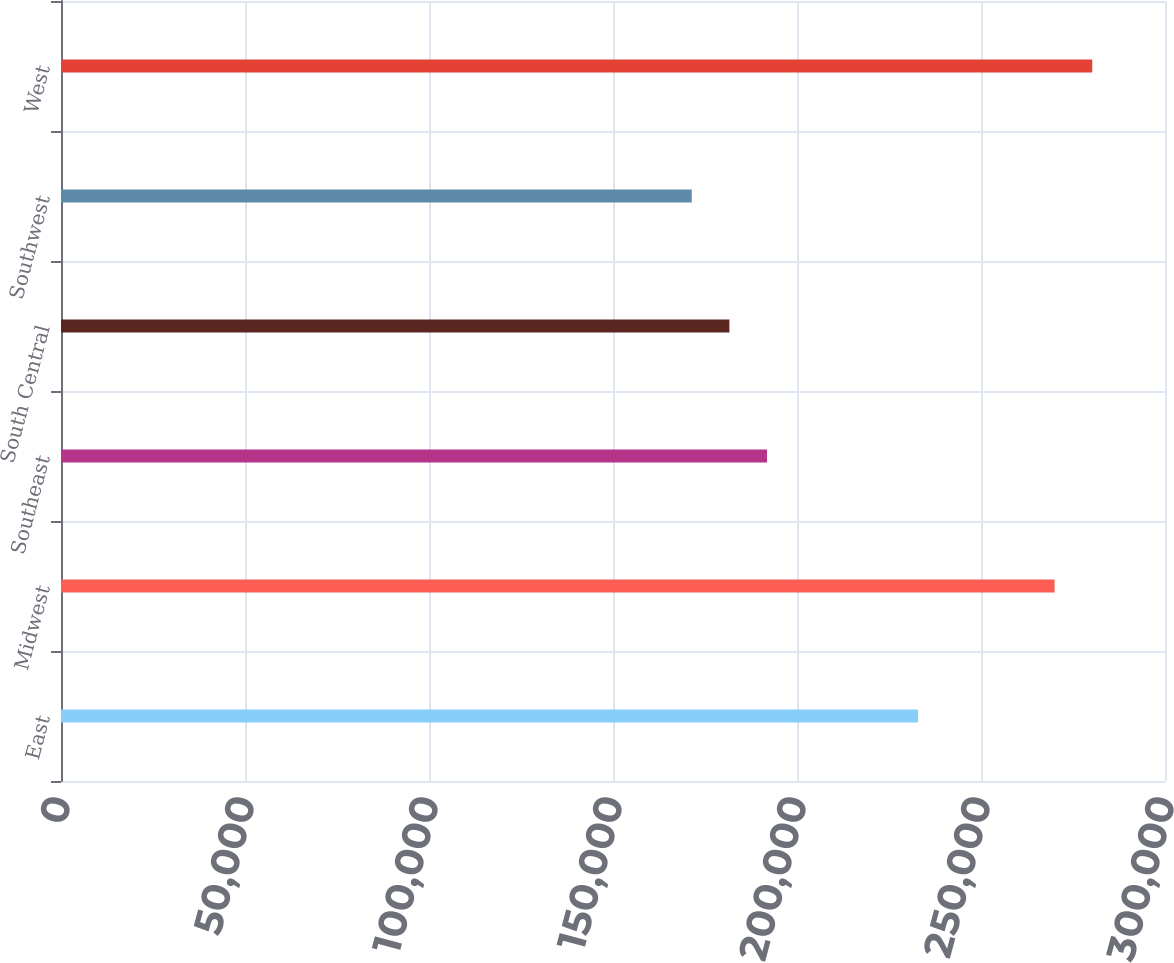Convert chart. <chart><loc_0><loc_0><loc_500><loc_500><bar_chart><fcel>East<fcel>Midwest<fcel>Southeast<fcel>South Central<fcel>Southwest<fcel>West<nl><fcel>232900<fcel>270000<fcel>191860<fcel>181630<fcel>171400<fcel>280230<nl></chart> 